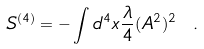<formula> <loc_0><loc_0><loc_500><loc_500>S ^ { ( 4 ) } = - \int d ^ { 4 } x \frac { \lambda } { 4 } ( A ^ { 2 } ) ^ { 2 } \ .</formula> 